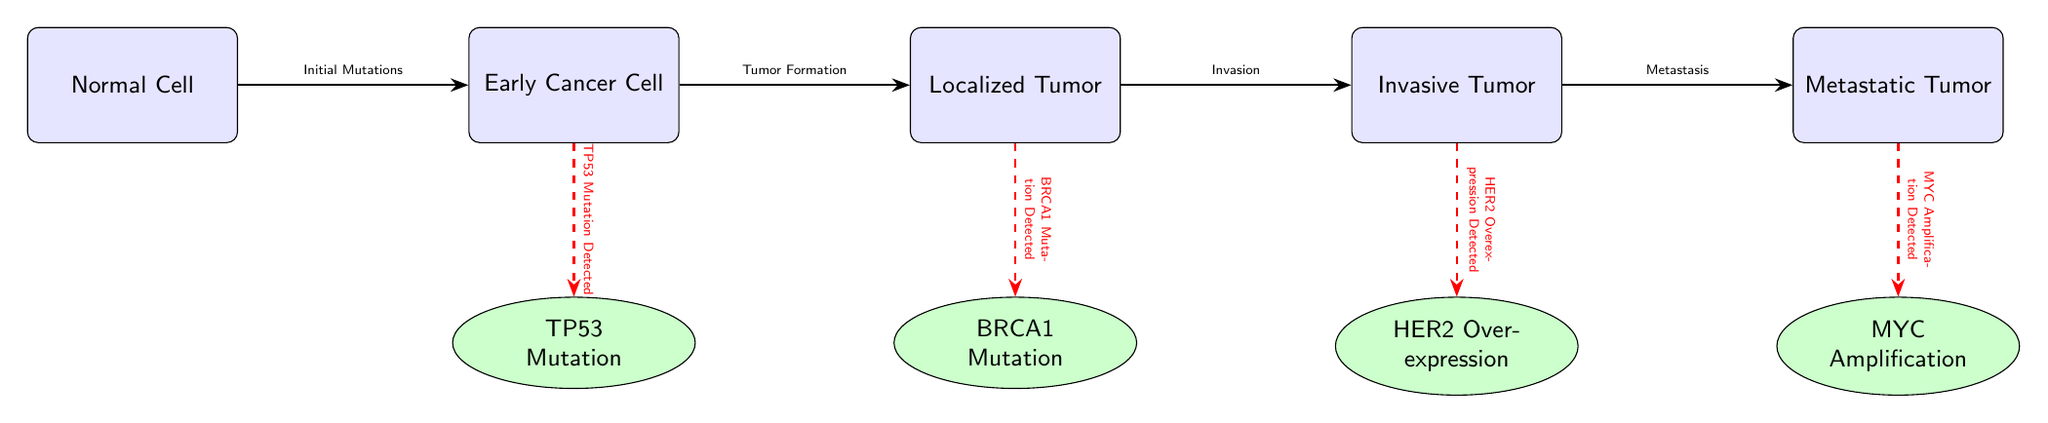What is the first stage in cancer development according to the diagram? The diagram shows the progression of cancer from one stage to the next. The first stage is "Normal Cell," indicating the starting point before any mutations or cancer development occur.
Answer: Normal Cell How many gene mutations are detected in the invasive tumor stage? The invasive tumor stage is connected to one gene mutation, which is "HER2 Overexpression Detected." According to the diagram, it shows a dashed red line leading from the invasive tumor to HER2.
Answer: 1 What is the relationship between localized tumor and invasive tumor? The arrow connecting the "Localized Tumor" to the "Invasive Tumor" is labeled "Invasion," indicating that the localized tumor progresses into an invasive tumor through this process.
Answer: Invasion What mutation is detected in the early cancer cell stage? The diagram indicates that the "Early Cancer Cell" stage is associated with the detection of "TP53 Mutation" as seen by the dashed red line from early cancer cell to TP53.
Answer: TP53 Mutation Which cancer stage shows myc amplification? The diagram indicates myc amplification is detected in the "Metastatic Tumor" stage, as the dashed line from the metastatic tumor leads to MYC Amplification.
Answer: Metastatic Tumor What is the final stage of cancer development shown in the diagram? The diagram progresses through various cancer stages, leading to the last cell type represented, which is "Metastatic Tumor," indicating advanced cancer that has spread.
Answer: Metastatic Tumor What is the common theme of the arrows connecting the stages? Each arrow in the diagram represents a specific process or transition from one stage of cancer to the next, while the dashed lines signify the detection of mutations associated with each respective cell type.
Answer: Progression and Detection 